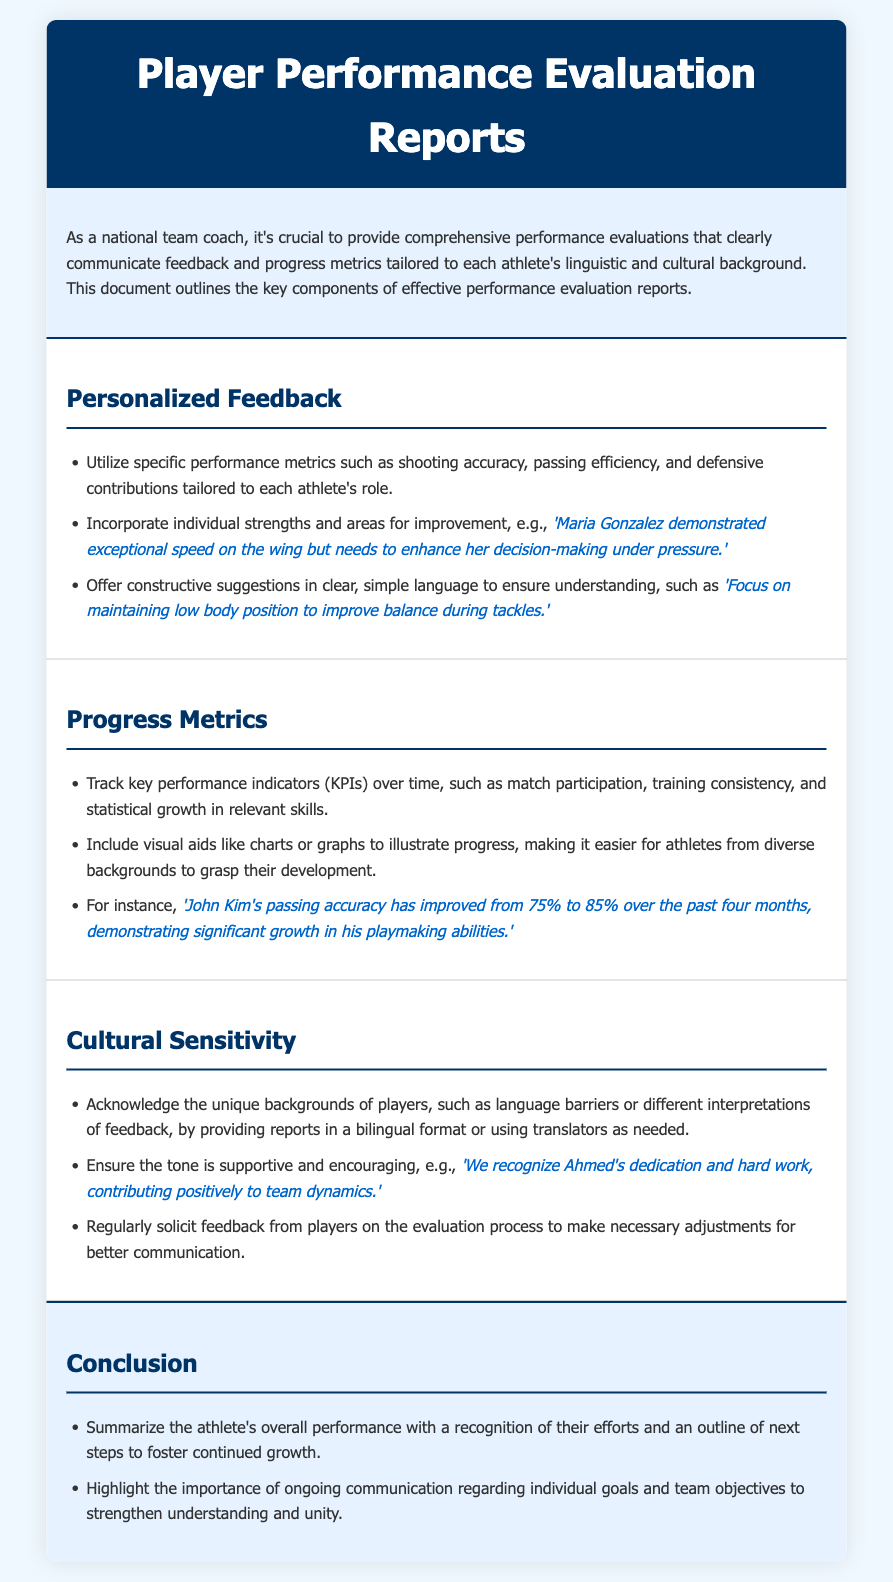what is the title of the document? The title of the document is specified in the header section of the HTML, which is "Player Performance Evaluation Reports."
Answer: Player Performance Evaluation Reports what is one example of personalized feedback? The document provides an example of personalized feedback highlighting an athlete's strengths and areas for improvement.
Answer: 'Maria Gonzalez demonstrated exceptional speed on the wing but needs to enhance her decision-making under pressure.' what metric improved for John Kim? The document states a specific performance metric that improved for John Kim.
Answer: passing accuracy how much did John Kim's passing accuracy improve? The document quantifies the improvement in John Kim's passing accuracy over time.
Answer: from 75% to 85% what key performance indicators (KPIs) are tracked? The document lists the types of performance indicators being monitored for athletes.
Answer: match participation, training consistency, and statistical growth how is cultural sensitivity addressed? The document explains how cultural sensitivity is incorporated in performance evaluations.
Answer: by providing reports in a bilingual format or using translators what is the color of the header background? The background color of the header section is stated in the document.
Answer: #003366 what is emphasized in the conclusion section? The conclusion section emphasizes a specific aspect regarding athletes' performance.
Answer: overall performance and growth 